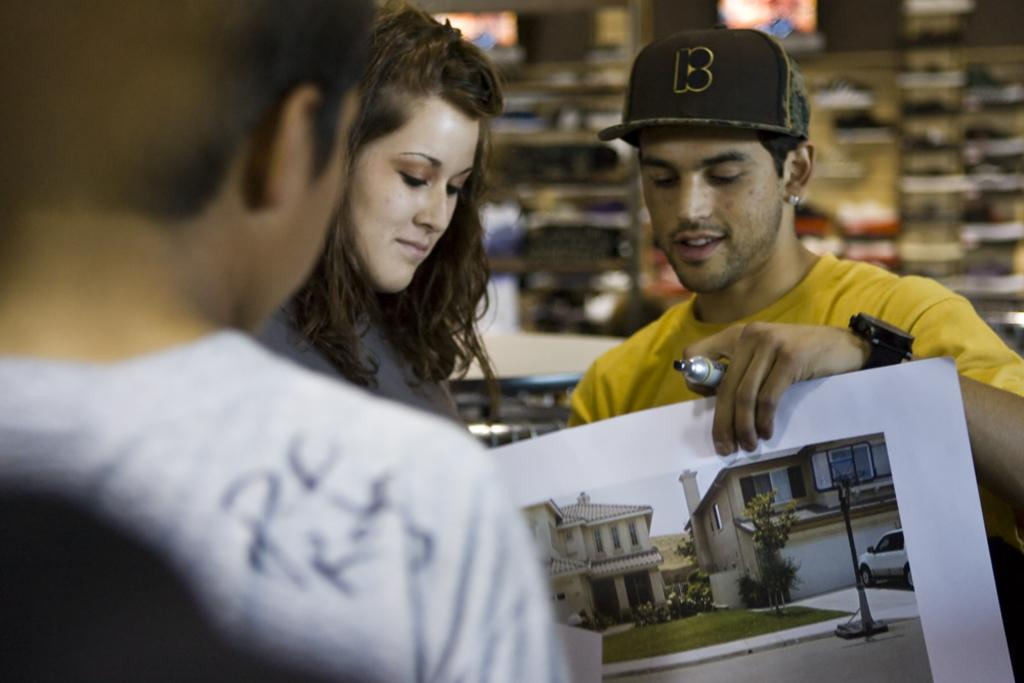How many people are in the image? There are people in the image, but the exact number is not specified. What is the man wearing on his head? The man is wearing a cap. What is the man holding in his hand? The man is holding a paper and a marker. What is the primary object in the image that people might gather around? There is a table in the image, which could be a gathering point. What is the background of the image? There is a wall in the image, which serves as the background. What type of fruit is being mined in the image? There is no fruit or mine present in the image. Can you provide an example of a similar situation to the one depicted in the image? It is not possible to provide an example of a similar situation since the image's context is not clear. 